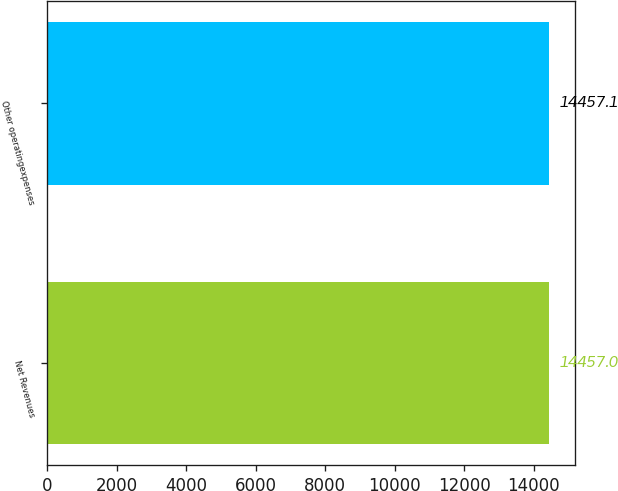<chart> <loc_0><loc_0><loc_500><loc_500><bar_chart><fcel>Net Revenues<fcel>Other operatingexpenses<nl><fcel>14457<fcel>14457.1<nl></chart> 